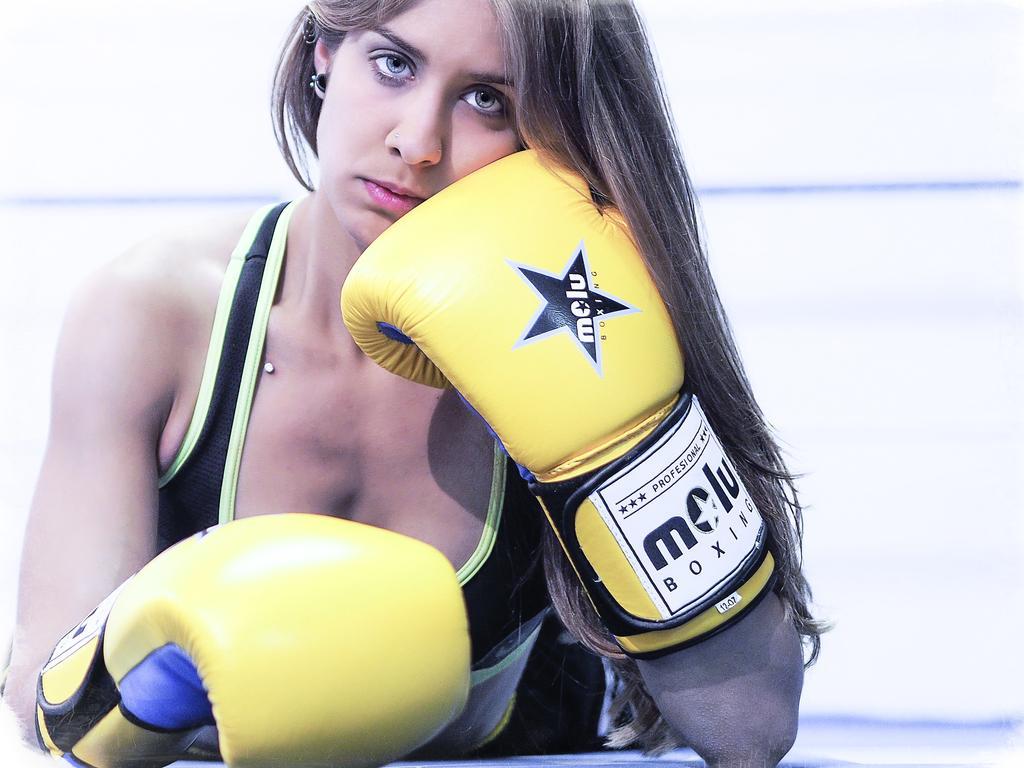How would you summarize this image in a sentence or two? In this image there is a woman with boxing gloves is laying on the path , and there is white color background. 